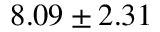Convert formula to latex. <formula><loc_0><loc_0><loc_500><loc_500>8 . 0 9 \pm 2 . 3 1</formula> 